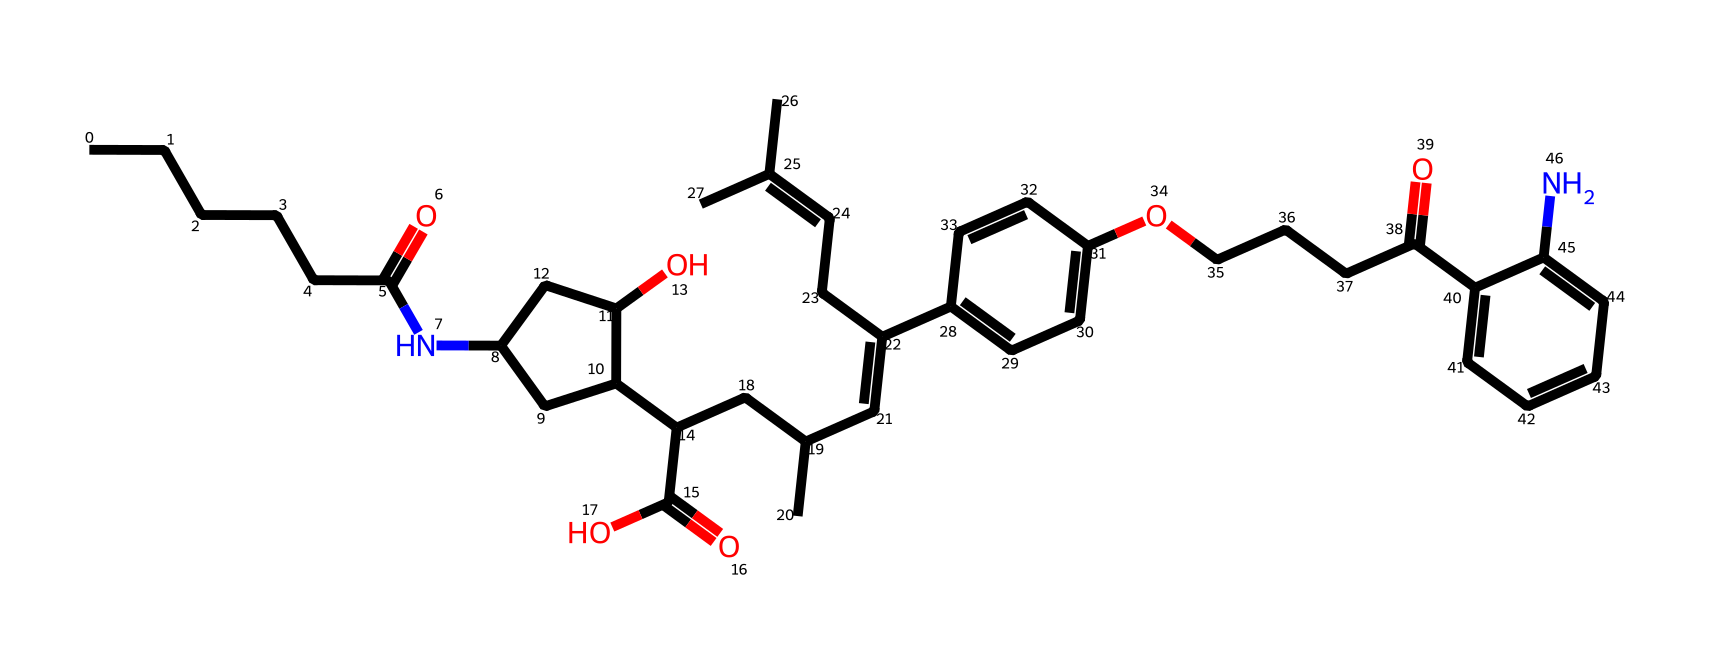What is the main functional group present in this compound? The compound contains an amine group (N attached to carbon chains) amidst multiple functional groups, but the most prominent is the presence of a carboxylic acid (–COOH) group.
Answer: carboxylic acid How many rings are present in this chemical structure? By examining the structural representation, we can identify that there are two distinct cyclic structures (rings) in the compound, which are part of its complex molecular architecture.
Answer: 2 What type of drug classification does this compound belong to? The compound is primarily classified as a statin, a type of drug that is used to lower cholesterol levels in the blood, indicated by its structure and known pharmacological properties.
Answer: statin What is the total number of carbon atoms in this molecule? Counting the carbon atoms in the SMILES notation reveals that there are 31 carbon atoms present in the chemical structure, which is fundamental for understanding its molecular composition.
Answer: 31 Which parts of this chemical structure are likely responsible for its cholesterol-lowering effect? The presence of the lactone ring and specific functional groups (like the hydroxy) increase the drug's ability to inhibit HMG-CoA reductase, an enzyme crucial in cholesterol biosynthesis, thus playing a significant role in its mechanism.
Answer: lactone ring 